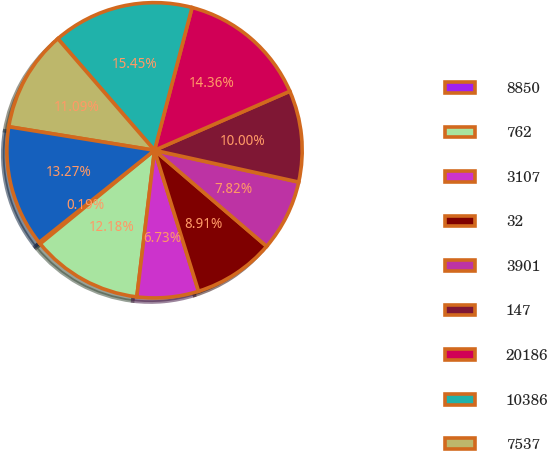<chart> <loc_0><loc_0><loc_500><loc_500><pie_chart><fcel>8850<fcel>762<fcel>3107<fcel>32<fcel>3901<fcel>147<fcel>20186<fcel>10386<fcel>7537<fcel>38109<nl><fcel>0.19%<fcel>12.18%<fcel>6.73%<fcel>8.91%<fcel>7.82%<fcel>10.0%<fcel>14.36%<fcel>15.45%<fcel>11.09%<fcel>13.27%<nl></chart> 